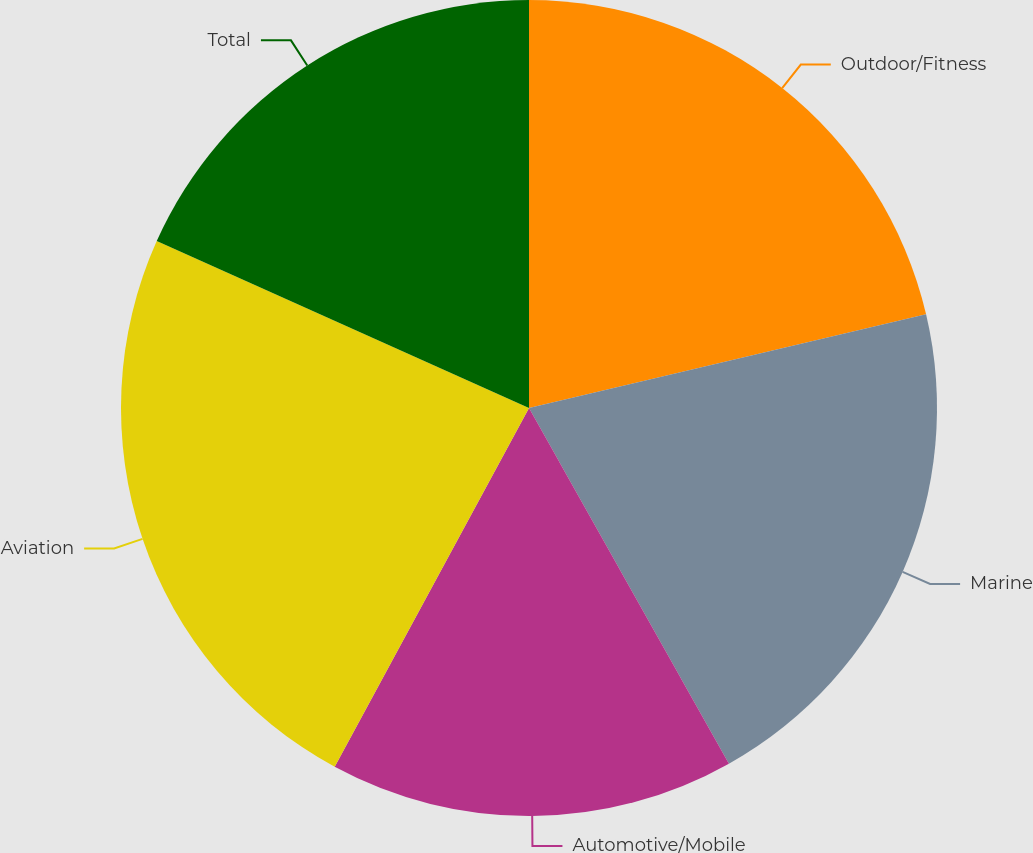Convert chart. <chart><loc_0><loc_0><loc_500><loc_500><pie_chart><fcel>Outdoor/Fitness<fcel>Marine<fcel>Automotive/Mobile<fcel>Aviation<fcel>Total<nl><fcel>21.31%<fcel>20.54%<fcel>16.05%<fcel>23.81%<fcel>18.29%<nl></chart> 